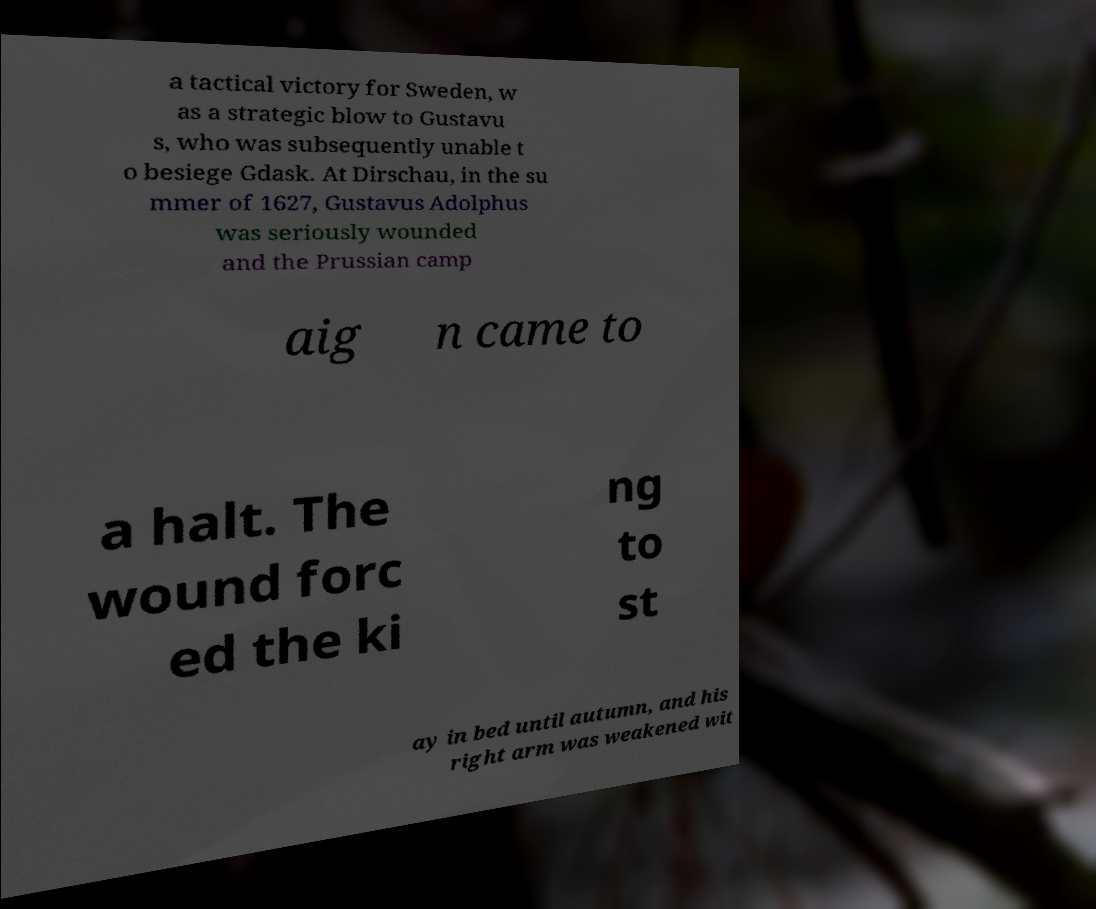Can you accurately transcribe the text from the provided image for me? a tactical victory for Sweden, w as a strategic blow to Gustavu s, who was subsequently unable t o besiege Gdask. At Dirschau, in the su mmer of 1627, Gustavus Adolphus was seriously wounded and the Prussian camp aig n came to a halt. The wound forc ed the ki ng to st ay in bed until autumn, and his right arm was weakened wit 